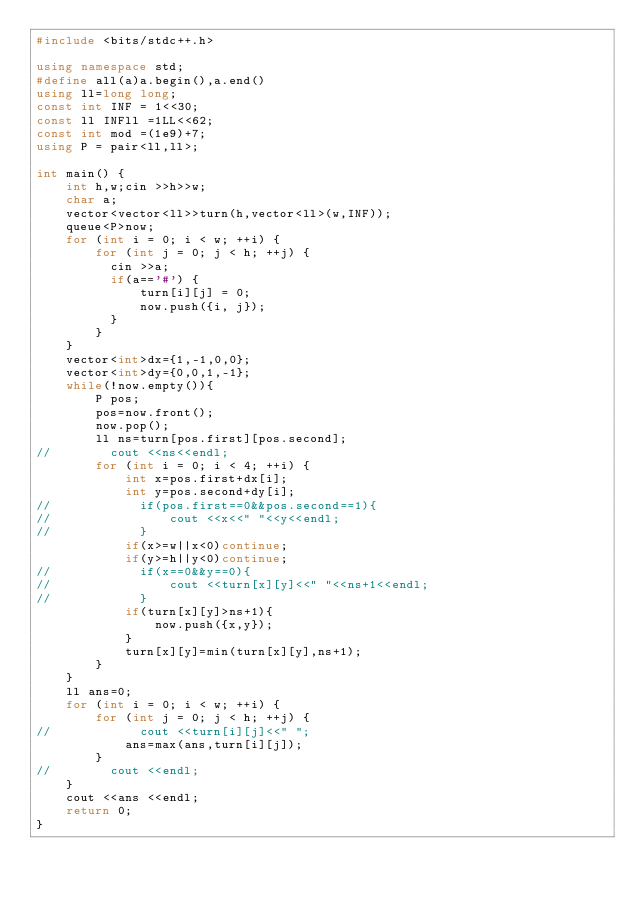<code> <loc_0><loc_0><loc_500><loc_500><_C++_>#include <bits/stdc++.h>

using namespace std;
#define all(a)a.begin(),a.end()
using ll=long long;
const int INF = 1<<30;
const ll INFll =1LL<<62;
const int mod =(1e9)+7;
using P = pair<ll,ll>;

int main() {
    int h,w;cin >>h>>w;
    char a;
    vector<vector<ll>>turn(h,vector<ll>(w,INF));
    queue<P>now;
    for (int i = 0; i < w; ++i) {
        for (int j = 0; j < h; ++j) {
          cin >>a;
          if(a=='#') {
              turn[i][j] = 0;
              now.push({i, j});
          }
        }
    }
    vector<int>dx={1,-1,0,0};
    vector<int>dy={0,0,1,-1};
    while(!now.empty()){
        P pos;
        pos=now.front();
        now.pop();
        ll ns=turn[pos.first][pos.second];
//        cout <<ns<<endl;
        for (int i = 0; i < 4; ++i) {
            int x=pos.first+dx[i];
            int y=pos.second+dy[i];
//            if(pos.first==0&&pos.second==1){
//                cout <<x<<" "<<y<<endl;
//            }
            if(x>=w||x<0)continue;
            if(y>=h||y<0)continue;
//            if(x==0&&y==0){
//                cout <<turn[x][y]<<" "<<ns+1<<endl;
//            }
            if(turn[x][y]>ns+1){
                now.push({x,y});
            }
            turn[x][y]=min(turn[x][y],ns+1);
        }
    }
    ll ans=0;
    for (int i = 0; i < w; ++i) {
        for (int j = 0; j < h; ++j) {
//            cout <<turn[i][j]<<" ";
            ans=max(ans,turn[i][j]);
        }
//        cout <<endl;
    }
    cout <<ans <<endl;
    return 0;
}

</code> 